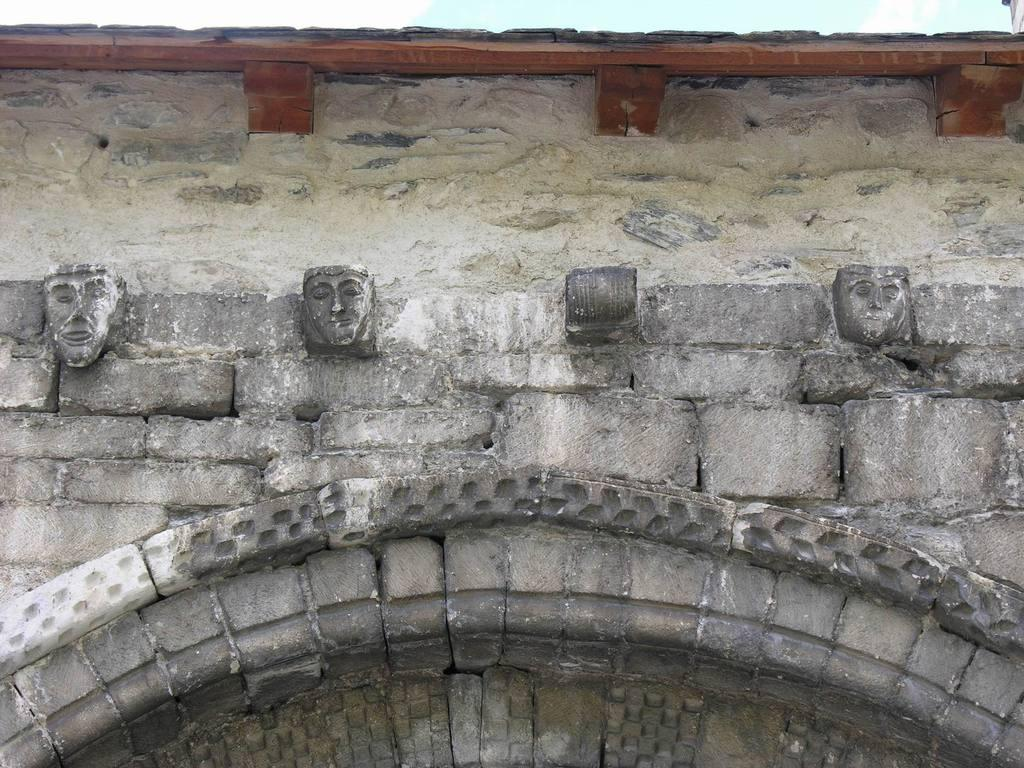What is the main feature of the image? There is a wall in the image. What is depicted on the wall? Sculptures are carved on the wall. What type of horn can be seen on the farm in the image? There is no farm or horn present in the image; it only features a wall with sculptures. 